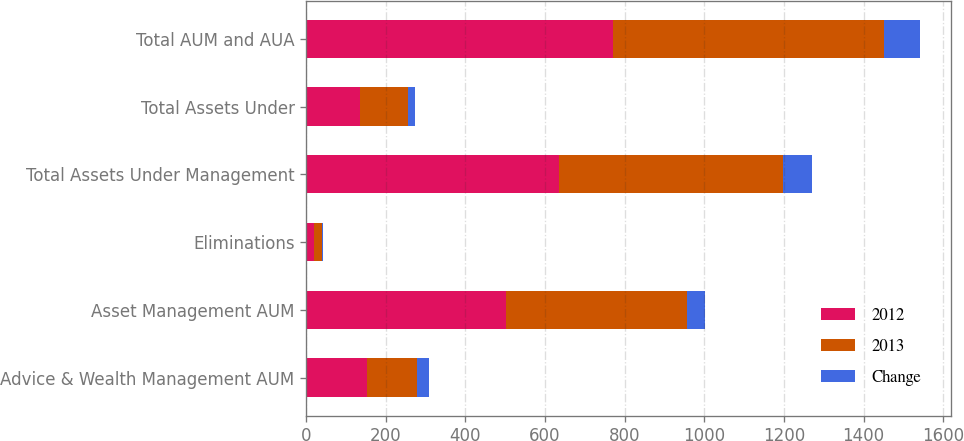Convert chart to OTSL. <chart><loc_0><loc_0><loc_500><loc_500><stacked_bar_chart><ecel><fcel>Advice & Wealth Management AUM<fcel>Asset Management AUM<fcel>Eliminations<fcel>Total Assets Under Management<fcel>Total Assets Under<fcel>Total AUM and AUA<nl><fcel>2012<fcel>154<fcel>500.8<fcel>20.5<fcel>635.2<fcel>136.1<fcel>771.3<nl><fcel>2013<fcel>125<fcel>455.4<fcel>18<fcel>562.4<fcel>118.6<fcel>681<nl><fcel>Change<fcel>29<fcel>45.4<fcel>2.5<fcel>72.8<fcel>17.5<fcel>90.3<nl></chart> 